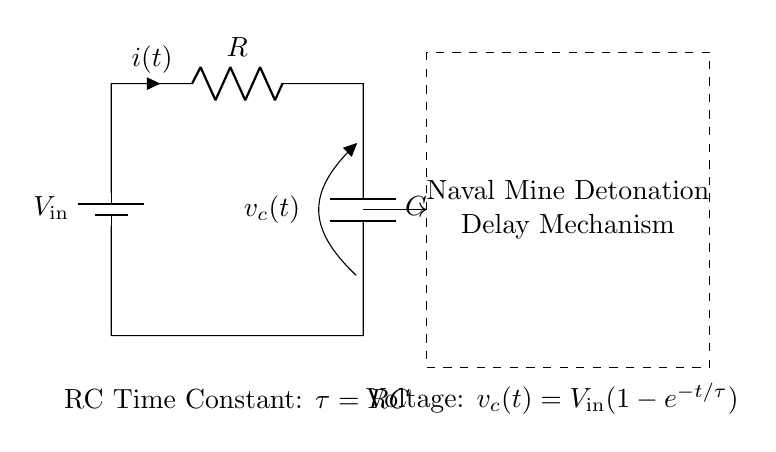What is the type of this circuit? This circuit is an RC timing circuit, as it consists of a resistor and a capacitor. This designation is immediately suggested by the presence of an R and a C in the circuit diagram.
Answer: RC timing circuit What components are present in this circuit? The components shown are a battery (V_in), a resistor (R), and a capacitor (C). These elements are indicated explicitly in the circuit labeled accordingly.
Answer: Battery, Resistor, Capacitor What is the equation for the voltage across the capacitor? The equation provided in the diagram for the voltage across the capacitor is v_c(t) = V_in(1-e^{-t/τ}). This has been directly stated within the circuit, linking voltage to the time constant τ.
Answer: v_c(t) = V_in(1-e^{-t/τ}) What does τ represent in this circuit? τ represents the time constant of the RC circuit, which is calculated as the product of the resistance (R) and the capacitance (C). It's a critical parameter for determining the charging and discharging rate of the capacitor.
Answer: τ = RC What is the relationship between time constant τ and the rate of charge? The time constant τ defines how quickly the capacitor charges or discharges. A larger τ indicates a slower rate of charge, while a smaller τ signifies a faster rate of charge due to less resistance or capacitance.
Answer: It impacts charge rate How does changing the resistor value affect the timing of this mechanism? Decreasing the resistor value (R) would decrease τ, resulting in a faster charge time for the capacitor. Conversely, increasing R would increase τ, leading to slower charging and a longer delay for the detonation. This understanding comes from the τ = RC relationship.
Answer: It alters the timing delay Why is this RC timing circuit used in a naval mine detonation mechanism? The RC timing circuit allows for precise control over the time delay before detonation. By adjusting R and C, engineers can set specific delays, enhancing strategic deployment of naval mines while minimizing false activations.
Answer: To control detonation delay 